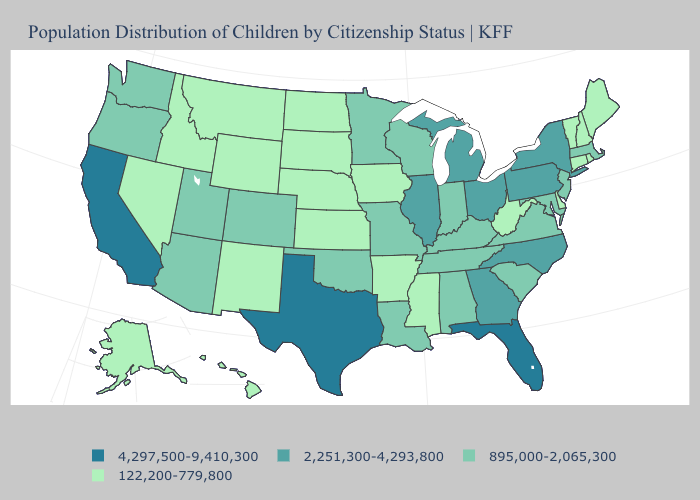Does the map have missing data?
Write a very short answer. No. Among the states that border Pennsylvania , does Delaware have the highest value?
Be succinct. No. What is the value of Kansas?
Short answer required. 122,200-779,800. Name the states that have a value in the range 895,000-2,065,300?
Be succinct. Alabama, Arizona, Colorado, Indiana, Kentucky, Louisiana, Maryland, Massachusetts, Minnesota, Missouri, New Jersey, Oklahoma, Oregon, South Carolina, Tennessee, Utah, Virginia, Washington, Wisconsin. Does the map have missing data?
Keep it brief. No. Among the states that border Minnesota , does South Dakota have the lowest value?
Short answer required. Yes. Which states hav the highest value in the South?
Concise answer only. Florida, Texas. Which states have the lowest value in the USA?
Write a very short answer. Alaska, Arkansas, Connecticut, Delaware, Hawaii, Idaho, Iowa, Kansas, Maine, Mississippi, Montana, Nebraska, Nevada, New Hampshire, New Mexico, North Dakota, Rhode Island, South Dakota, Vermont, West Virginia, Wyoming. Name the states that have a value in the range 2,251,300-4,293,800?
Quick response, please. Georgia, Illinois, Michigan, New York, North Carolina, Ohio, Pennsylvania. What is the value of South Carolina?
Keep it brief. 895,000-2,065,300. Does New Mexico have the highest value in the USA?
Be succinct. No. What is the value of Utah?
Concise answer only. 895,000-2,065,300. What is the value of Ohio?
Short answer required. 2,251,300-4,293,800. Does the first symbol in the legend represent the smallest category?
Give a very brief answer. No. Does Maryland have the lowest value in the USA?
Concise answer only. No. 